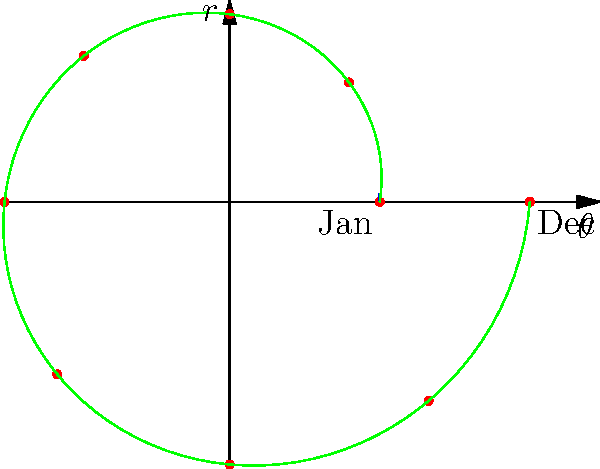The polar plot shows the stock price of Arista Networks throughout a year, with the radius representing the price and the angle representing time (January at $\theta=0$, December at $\theta=2\pi$). The blue circle represents the starting price, and the green spiral shows the price trend. What does this graph indicate about Arista Networks' stock performance over the year? To analyze Arista Networks' stock performance over the year:

1. Observe the starting point: The blue circle represents the initial stock price in January.

2. Follow the green spiral: This shows the price trend throughout the year.

3. Compare the spiral to the blue circle:
   - The spiral moves outward from the center as $\theta$ increases.
   - At $\theta=2\pi$ (December), the spiral is significantly outside the blue circle.

4. Interpret the radial distance:
   - Greater distance from the center indicates a higher stock price.
   - The increasing radial distance shows a consistent price increase over time.

5. Quantify the growth:
   - The spiral starts at $r=120$ (January price)
   - It ends at $r=240$ (December price)
   - This represents a 100% increase in stock price over the year.

6. Note the steady growth:
   - The spiral's smooth outward progression suggests consistent growth without major fluctuations.

Therefore, the graph indicates that Arista Networks' stock price doubled over the course of the year, showing strong and steady growth.
Answer: Strong, steady growth; stock price doubled 